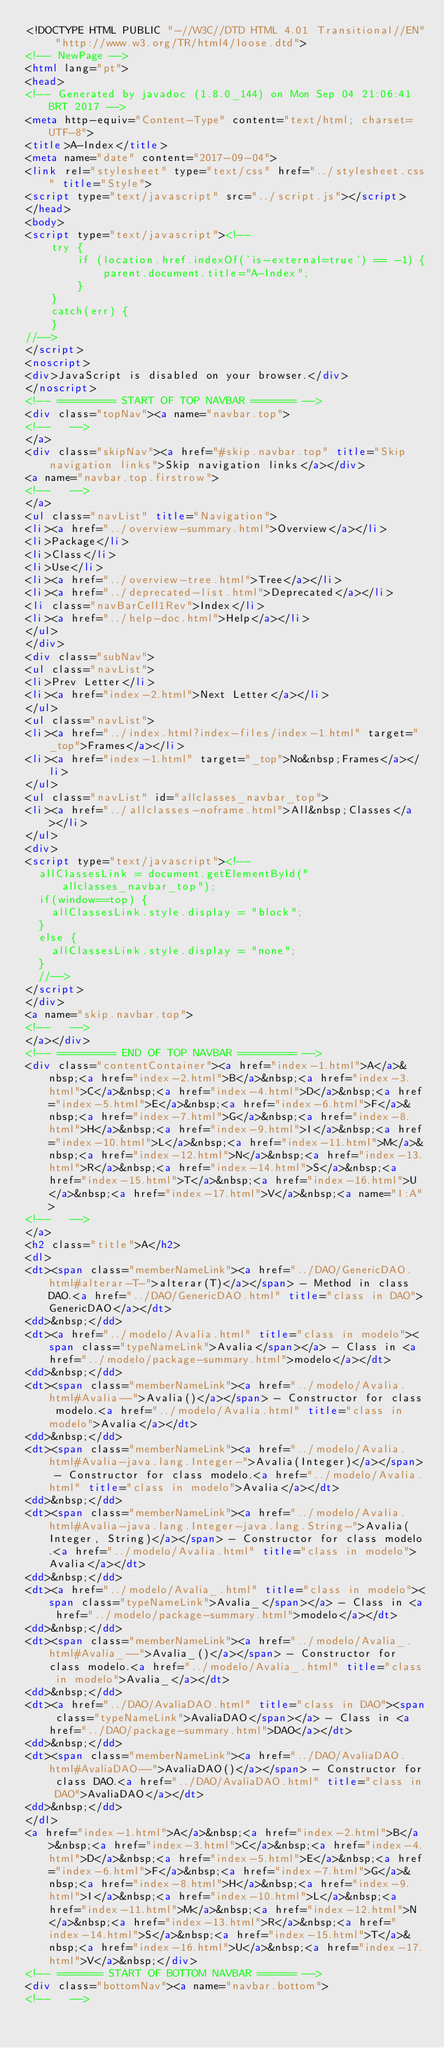<code> <loc_0><loc_0><loc_500><loc_500><_HTML_><!DOCTYPE HTML PUBLIC "-//W3C//DTD HTML 4.01 Transitional//EN" "http://www.w3.org/TR/html4/loose.dtd">
<!-- NewPage -->
<html lang="pt">
<head>
<!-- Generated by javadoc (1.8.0_144) on Mon Sep 04 21:06:41 BRT 2017 -->
<meta http-equiv="Content-Type" content="text/html; charset=UTF-8">
<title>A-Index</title>
<meta name="date" content="2017-09-04">
<link rel="stylesheet" type="text/css" href="../stylesheet.css" title="Style">
<script type="text/javascript" src="../script.js"></script>
</head>
<body>
<script type="text/javascript"><!--
    try {
        if (location.href.indexOf('is-external=true') == -1) {
            parent.document.title="A-Index";
        }
    }
    catch(err) {
    }
//-->
</script>
<noscript>
<div>JavaScript is disabled on your browser.</div>
</noscript>
<!-- ========= START OF TOP NAVBAR ======= -->
<div class="topNav"><a name="navbar.top">
<!--   -->
</a>
<div class="skipNav"><a href="#skip.navbar.top" title="Skip navigation links">Skip navigation links</a></div>
<a name="navbar.top.firstrow">
<!--   -->
</a>
<ul class="navList" title="Navigation">
<li><a href="../overview-summary.html">Overview</a></li>
<li>Package</li>
<li>Class</li>
<li>Use</li>
<li><a href="../overview-tree.html">Tree</a></li>
<li><a href="../deprecated-list.html">Deprecated</a></li>
<li class="navBarCell1Rev">Index</li>
<li><a href="../help-doc.html">Help</a></li>
</ul>
</div>
<div class="subNav">
<ul class="navList">
<li>Prev Letter</li>
<li><a href="index-2.html">Next Letter</a></li>
</ul>
<ul class="navList">
<li><a href="../index.html?index-files/index-1.html" target="_top">Frames</a></li>
<li><a href="index-1.html" target="_top">No&nbsp;Frames</a></li>
</ul>
<ul class="navList" id="allclasses_navbar_top">
<li><a href="../allclasses-noframe.html">All&nbsp;Classes</a></li>
</ul>
<div>
<script type="text/javascript"><!--
  allClassesLink = document.getElementById("allclasses_navbar_top");
  if(window==top) {
    allClassesLink.style.display = "block";
  }
  else {
    allClassesLink.style.display = "none";
  }
  //-->
</script>
</div>
<a name="skip.navbar.top">
<!--   -->
</a></div>
<!-- ========= END OF TOP NAVBAR ========= -->
<div class="contentContainer"><a href="index-1.html">A</a>&nbsp;<a href="index-2.html">B</a>&nbsp;<a href="index-3.html">C</a>&nbsp;<a href="index-4.html">D</a>&nbsp;<a href="index-5.html">E</a>&nbsp;<a href="index-6.html">F</a>&nbsp;<a href="index-7.html">G</a>&nbsp;<a href="index-8.html">H</a>&nbsp;<a href="index-9.html">I</a>&nbsp;<a href="index-10.html">L</a>&nbsp;<a href="index-11.html">M</a>&nbsp;<a href="index-12.html">N</a>&nbsp;<a href="index-13.html">R</a>&nbsp;<a href="index-14.html">S</a>&nbsp;<a href="index-15.html">T</a>&nbsp;<a href="index-16.html">U</a>&nbsp;<a href="index-17.html">V</a>&nbsp;<a name="I:A">
<!--   -->
</a>
<h2 class="title">A</h2>
<dl>
<dt><span class="memberNameLink"><a href="../DAO/GenericDAO.html#alterar-T-">alterar(T)</a></span> - Method in class DAO.<a href="../DAO/GenericDAO.html" title="class in DAO">GenericDAO</a></dt>
<dd>&nbsp;</dd>
<dt><a href="../modelo/Avalia.html" title="class in modelo"><span class="typeNameLink">Avalia</span></a> - Class in <a href="../modelo/package-summary.html">modelo</a></dt>
<dd>&nbsp;</dd>
<dt><span class="memberNameLink"><a href="../modelo/Avalia.html#Avalia--">Avalia()</a></span> - Constructor for class modelo.<a href="../modelo/Avalia.html" title="class in modelo">Avalia</a></dt>
<dd>&nbsp;</dd>
<dt><span class="memberNameLink"><a href="../modelo/Avalia.html#Avalia-java.lang.Integer-">Avalia(Integer)</a></span> - Constructor for class modelo.<a href="../modelo/Avalia.html" title="class in modelo">Avalia</a></dt>
<dd>&nbsp;</dd>
<dt><span class="memberNameLink"><a href="../modelo/Avalia.html#Avalia-java.lang.Integer-java.lang.String-">Avalia(Integer, String)</a></span> - Constructor for class modelo.<a href="../modelo/Avalia.html" title="class in modelo">Avalia</a></dt>
<dd>&nbsp;</dd>
<dt><a href="../modelo/Avalia_.html" title="class in modelo"><span class="typeNameLink">Avalia_</span></a> - Class in <a href="../modelo/package-summary.html">modelo</a></dt>
<dd>&nbsp;</dd>
<dt><span class="memberNameLink"><a href="../modelo/Avalia_.html#Avalia_--">Avalia_()</a></span> - Constructor for class modelo.<a href="../modelo/Avalia_.html" title="class in modelo">Avalia_</a></dt>
<dd>&nbsp;</dd>
<dt><a href="../DAO/AvaliaDAO.html" title="class in DAO"><span class="typeNameLink">AvaliaDAO</span></a> - Class in <a href="../DAO/package-summary.html">DAO</a></dt>
<dd>&nbsp;</dd>
<dt><span class="memberNameLink"><a href="../DAO/AvaliaDAO.html#AvaliaDAO--">AvaliaDAO()</a></span> - Constructor for class DAO.<a href="../DAO/AvaliaDAO.html" title="class in DAO">AvaliaDAO</a></dt>
<dd>&nbsp;</dd>
</dl>
<a href="index-1.html">A</a>&nbsp;<a href="index-2.html">B</a>&nbsp;<a href="index-3.html">C</a>&nbsp;<a href="index-4.html">D</a>&nbsp;<a href="index-5.html">E</a>&nbsp;<a href="index-6.html">F</a>&nbsp;<a href="index-7.html">G</a>&nbsp;<a href="index-8.html">H</a>&nbsp;<a href="index-9.html">I</a>&nbsp;<a href="index-10.html">L</a>&nbsp;<a href="index-11.html">M</a>&nbsp;<a href="index-12.html">N</a>&nbsp;<a href="index-13.html">R</a>&nbsp;<a href="index-14.html">S</a>&nbsp;<a href="index-15.html">T</a>&nbsp;<a href="index-16.html">U</a>&nbsp;<a href="index-17.html">V</a>&nbsp;</div>
<!-- ======= START OF BOTTOM NAVBAR ====== -->
<div class="bottomNav"><a name="navbar.bottom">
<!--   --></code> 